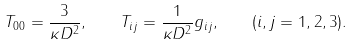Convert formula to latex. <formula><loc_0><loc_0><loc_500><loc_500>T _ { 0 0 } = \frac { 3 } { \kappa D ^ { 2 } } , \quad T _ { i j } = \frac { 1 } { \kappa D ^ { 2 } } g _ { i j } , \quad ( i , j = 1 , 2 , 3 ) .</formula> 